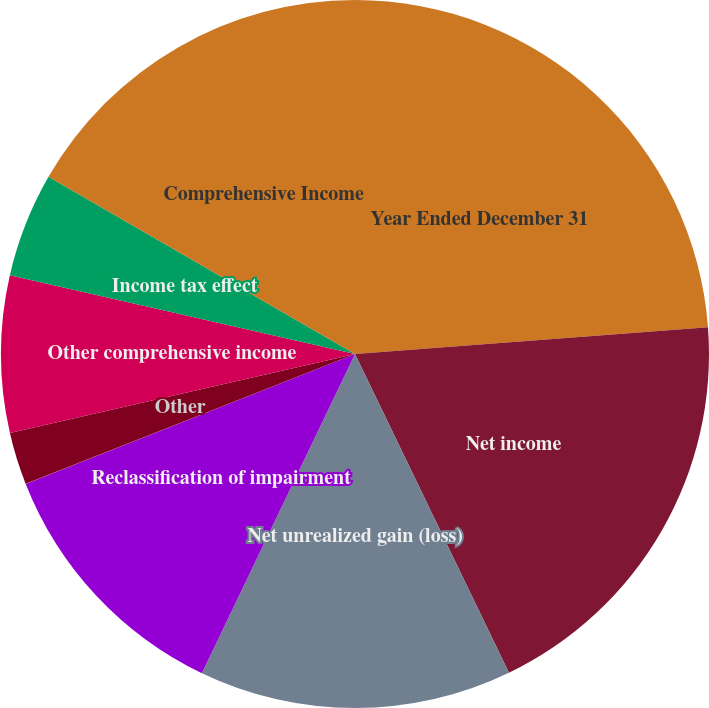Convert chart to OTSL. <chart><loc_0><loc_0><loc_500><loc_500><pie_chart><fcel>Year Ended December 31<fcel>Net income<fcel>Net unrealized gain (loss)<fcel>Reclassification of impairment<fcel>Other reclassifications<fcel>Other<fcel>Other comprehensive income<fcel>Income tax effect<fcel>Comprehensive Income<nl><fcel>23.8%<fcel>19.04%<fcel>14.28%<fcel>11.9%<fcel>0.01%<fcel>2.39%<fcel>7.15%<fcel>4.77%<fcel>16.66%<nl></chart> 